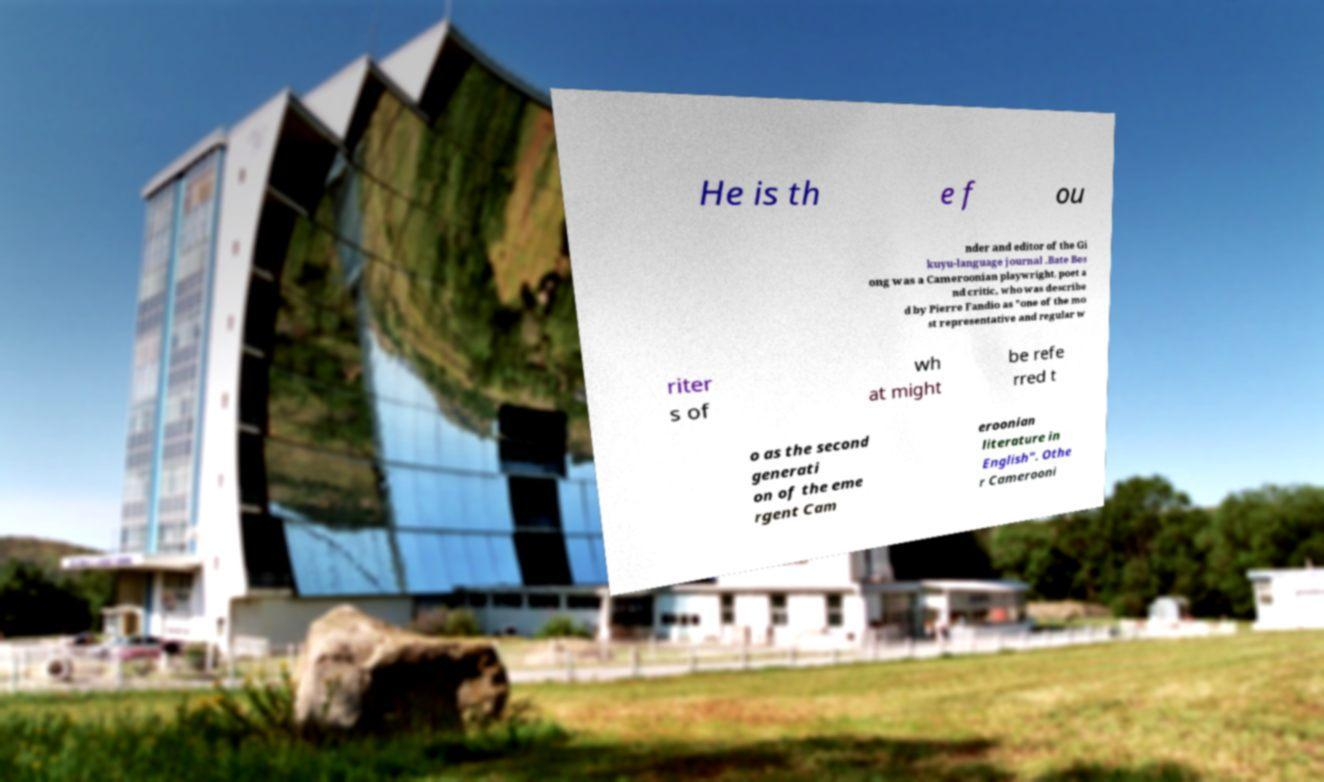For documentation purposes, I need the text within this image transcribed. Could you provide that? He is th e f ou nder and editor of the Gi kuyu-language journal .Bate Bes ong was a Cameroonian playwright, poet a nd critic, who was describe d by Pierre Fandio as "one of the mo st representative and regular w riter s of wh at might be refe rred t o as the second generati on of the eme rgent Cam eroonian literature in English". Othe r Camerooni 